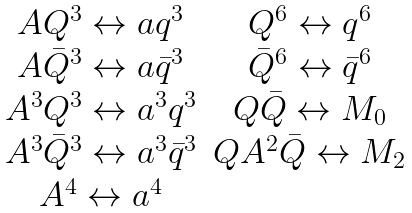<formula> <loc_0><loc_0><loc_500><loc_500>\begin{array} { c c } A Q ^ { 3 } \leftrightarrow a q ^ { 3 } & Q ^ { 6 } \leftrightarrow q ^ { 6 } \\ A \bar { Q } ^ { 3 } \leftrightarrow a \bar { q } ^ { 3 } & \bar { Q } ^ { 6 } \leftrightarrow \bar { q } ^ { 6 } \\ A ^ { 3 } Q ^ { 3 } \leftrightarrow a ^ { 3 } q ^ { 3 } & Q \bar { Q } \leftrightarrow M _ { 0 } \\ A ^ { 3 } \bar { Q } ^ { 3 } \leftrightarrow a ^ { 3 } \bar { q } ^ { 3 } & Q A ^ { 2 } \bar { Q } \leftrightarrow M _ { 2 } \\ A ^ { 4 } \leftrightarrow a ^ { 4 } & \end{array}</formula> 